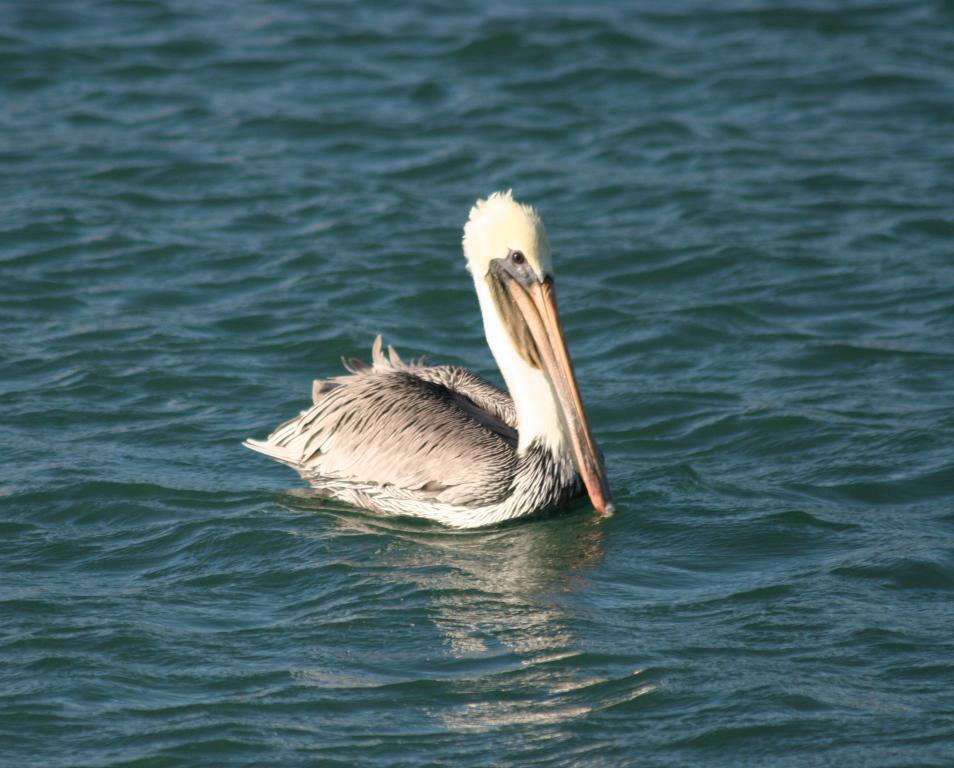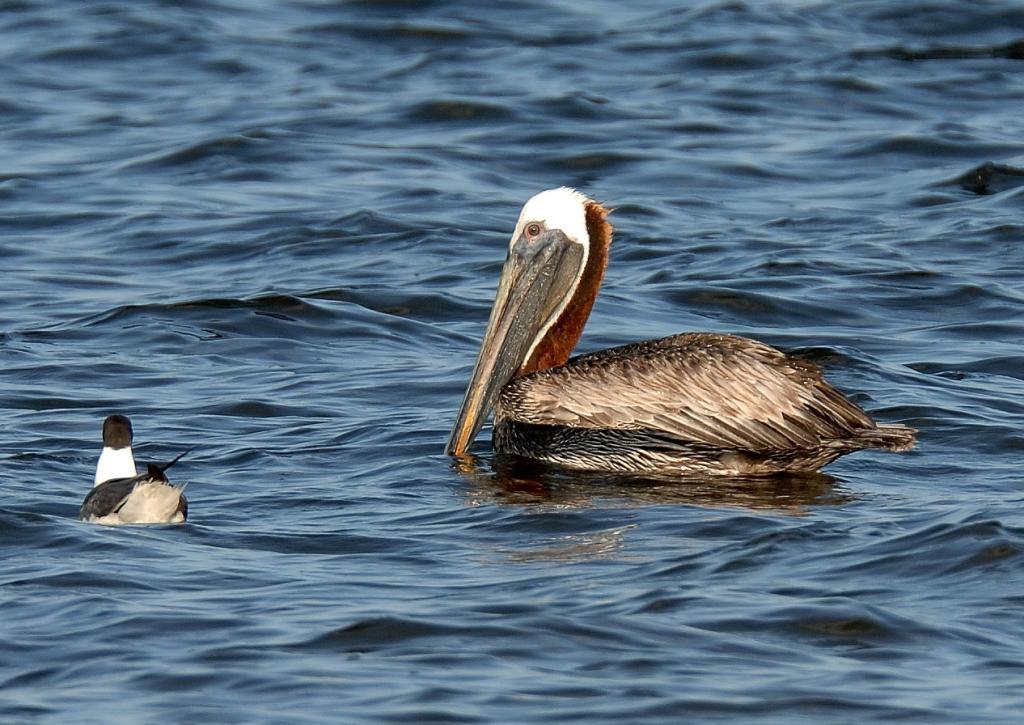The first image is the image on the left, the second image is the image on the right. Assess this claim about the two images: "There are exactly two birds in one of the images.". Correct or not? Answer yes or no. Yes. 